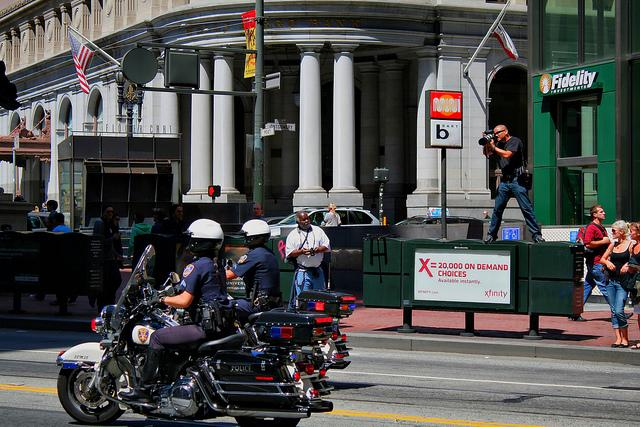What is the man standing on the green sign doing? filming 